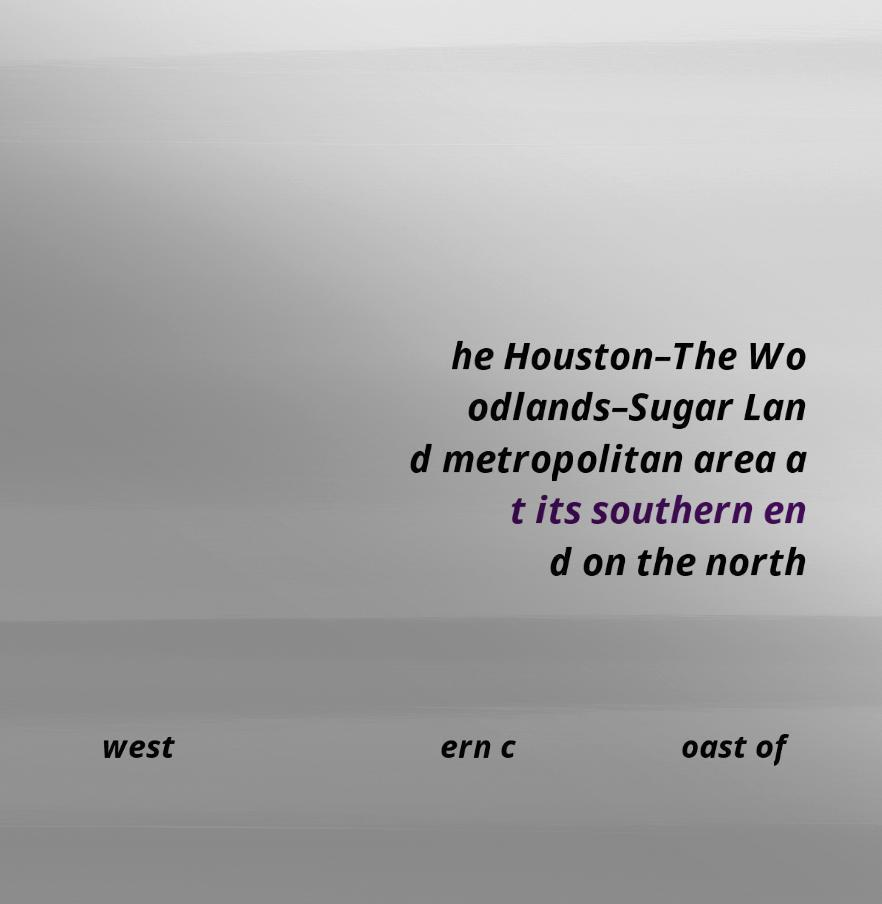Please identify and transcribe the text found in this image. he Houston–The Wo odlands–Sugar Lan d metropolitan area a t its southern en d on the north west ern c oast of 